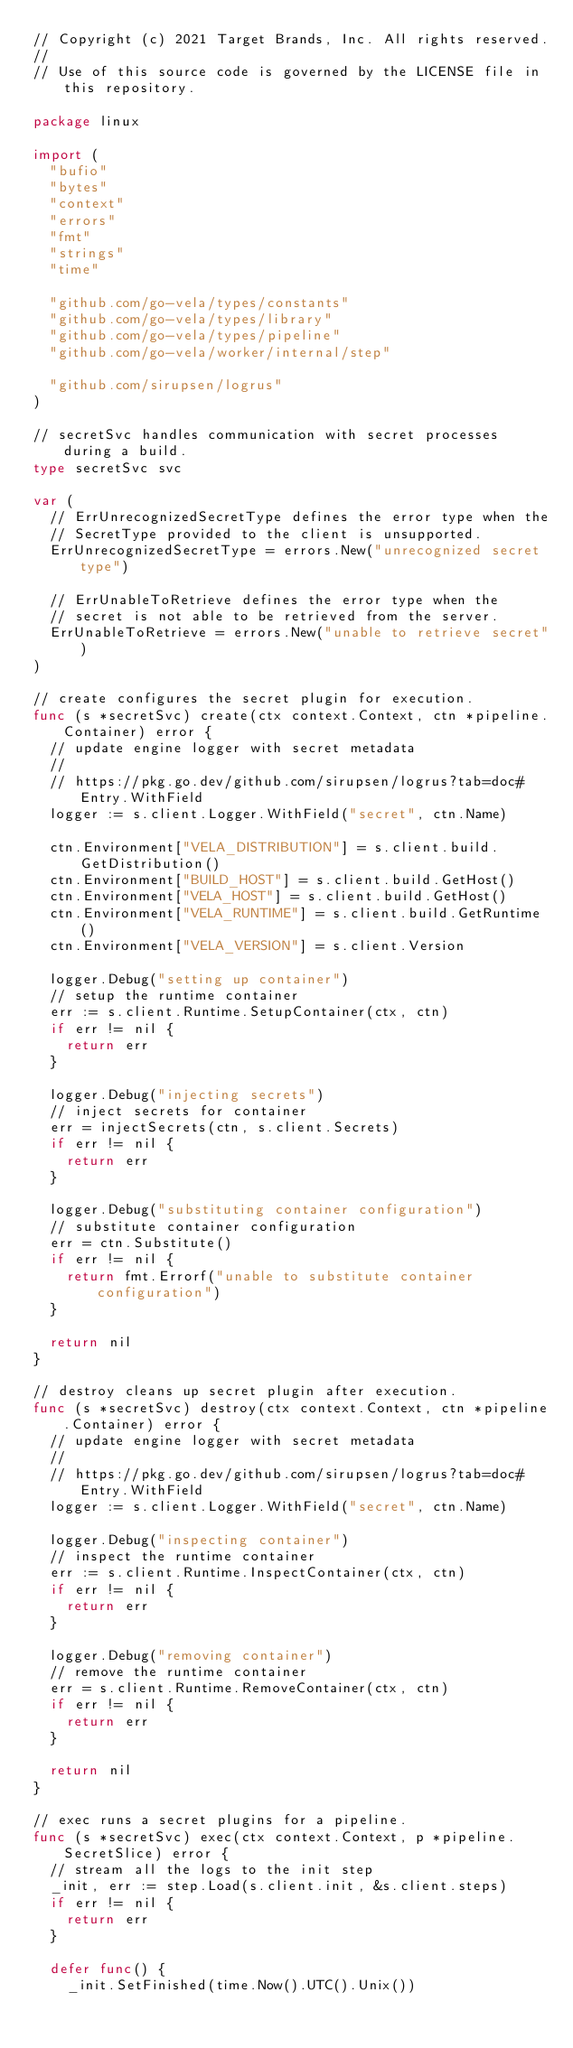Convert code to text. <code><loc_0><loc_0><loc_500><loc_500><_Go_>// Copyright (c) 2021 Target Brands, Inc. All rights reserved.
//
// Use of this source code is governed by the LICENSE file in this repository.

package linux

import (
	"bufio"
	"bytes"
	"context"
	"errors"
	"fmt"
	"strings"
	"time"

	"github.com/go-vela/types/constants"
	"github.com/go-vela/types/library"
	"github.com/go-vela/types/pipeline"
	"github.com/go-vela/worker/internal/step"

	"github.com/sirupsen/logrus"
)

// secretSvc handles communication with secret processes during a build.
type secretSvc svc

var (
	// ErrUnrecognizedSecretType defines the error type when the
	// SecretType provided to the client is unsupported.
	ErrUnrecognizedSecretType = errors.New("unrecognized secret type")

	// ErrUnableToRetrieve defines the error type when the
	// secret is not able to be retrieved from the server.
	ErrUnableToRetrieve = errors.New("unable to retrieve secret")
)

// create configures the secret plugin for execution.
func (s *secretSvc) create(ctx context.Context, ctn *pipeline.Container) error {
	// update engine logger with secret metadata
	//
	// https://pkg.go.dev/github.com/sirupsen/logrus?tab=doc#Entry.WithField
	logger := s.client.Logger.WithField("secret", ctn.Name)

	ctn.Environment["VELA_DISTRIBUTION"] = s.client.build.GetDistribution()
	ctn.Environment["BUILD_HOST"] = s.client.build.GetHost()
	ctn.Environment["VELA_HOST"] = s.client.build.GetHost()
	ctn.Environment["VELA_RUNTIME"] = s.client.build.GetRuntime()
	ctn.Environment["VELA_VERSION"] = s.client.Version

	logger.Debug("setting up container")
	// setup the runtime container
	err := s.client.Runtime.SetupContainer(ctx, ctn)
	if err != nil {
		return err
	}

	logger.Debug("injecting secrets")
	// inject secrets for container
	err = injectSecrets(ctn, s.client.Secrets)
	if err != nil {
		return err
	}

	logger.Debug("substituting container configuration")
	// substitute container configuration
	err = ctn.Substitute()
	if err != nil {
		return fmt.Errorf("unable to substitute container configuration")
	}

	return nil
}

// destroy cleans up secret plugin after execution.
func (s *secretSvc) destroy(ctx context.Context, ctn *pipeline.Container) error {
	// update engine logger with secret metadata
	//
	// https://pkg.go.dev/github.com/sirupsen/logrus?tab=doc#Entry.WithField
	logger := s.client.Logger.WithField("secret", ctn.Name)

	logger.Debug("inspecting container")
	// inspect the runtime container
	err := s.client.Runtime.InspectContainer(ctx, ctn)
	if err != nil {
		return err
	}

	logger.Debug("removing container")
	// remove the runtime container
	err = s.client.Runtime.RemoveContainer(ctx, ctn)
	if err != nil {
		return err
	}

	return nil
}

// exec runs a secret plugins for a pipeline.
func (s *secretSvc) exec(ctx context.Context, p *pipeline.SecretSlice) error {
	// stream all the logs to the init step
	_init, err := step.Load(s.client.init, &s.client.steps)
	if err != nil {
		return err
	}

	defer func() {
		_init.SetFinished(time.Now().UTC().Unix())
</code> 